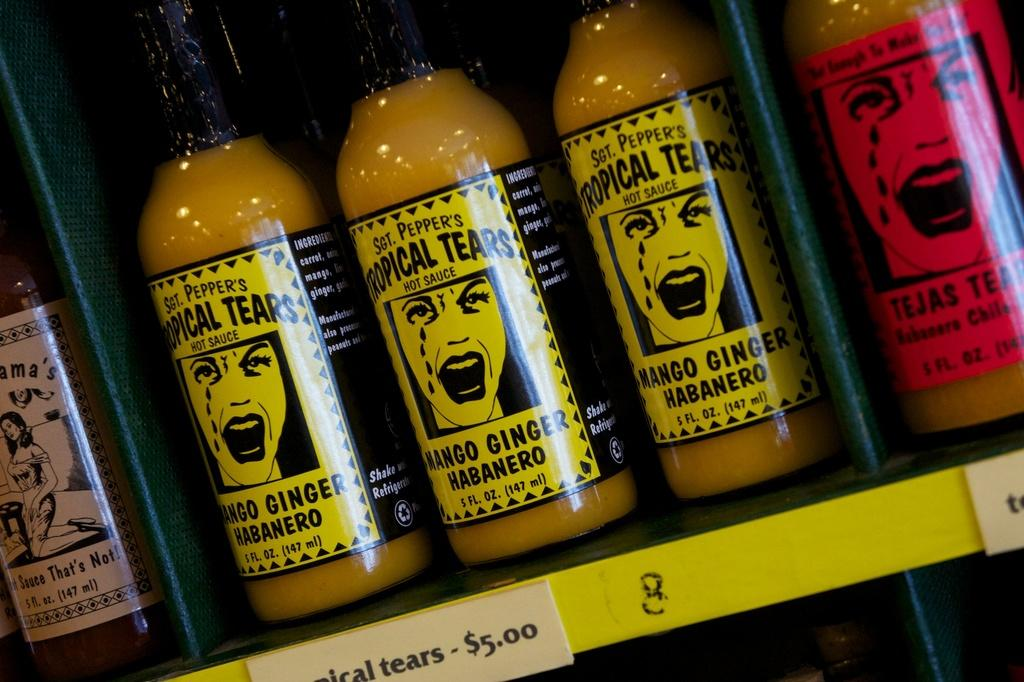<image>
Create a compact narrative representing the image presented. three bottles of tropical tears hot sauce being sold for $5.00 